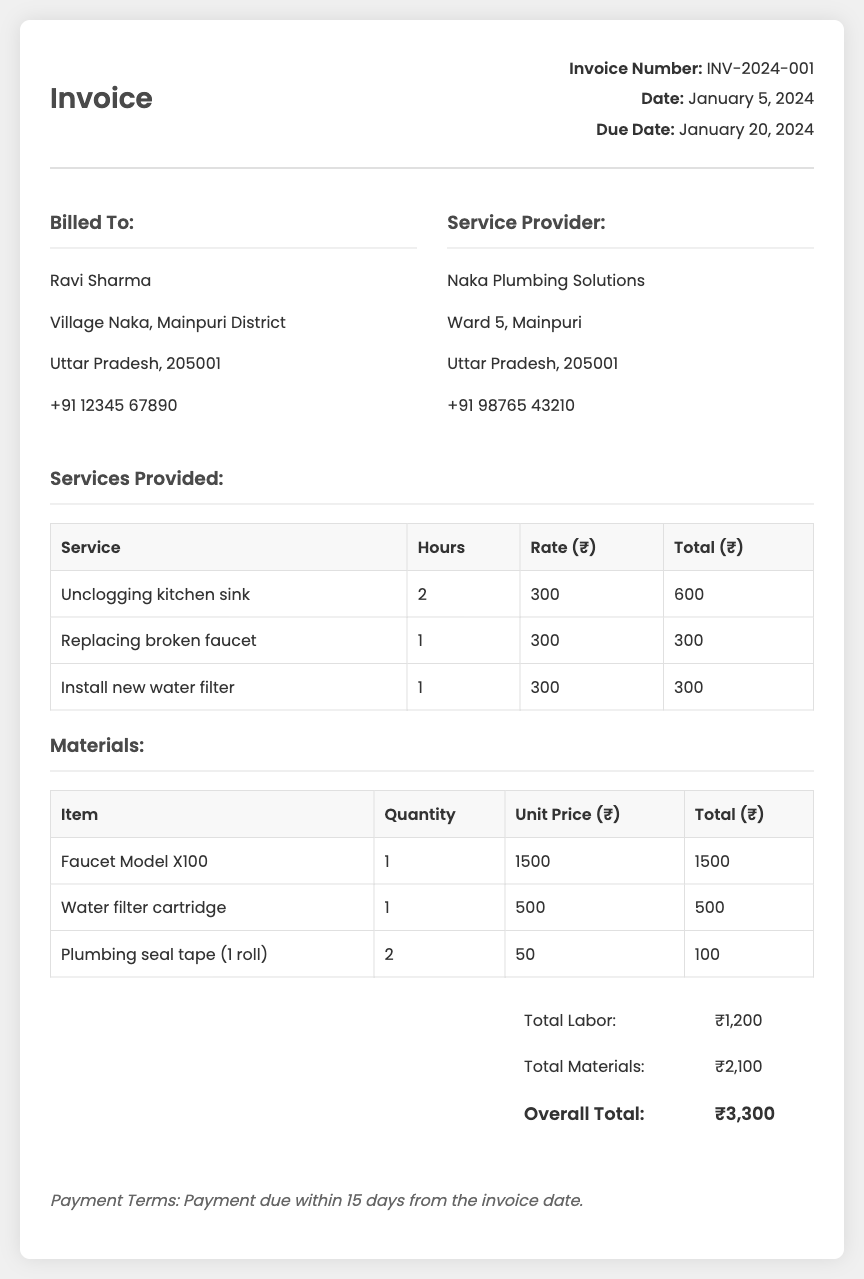What is the invoice number? The invoice number is listed at the top of the document for reference.
Answer: INV-2024-001 What is the total for materials? The total for materials is calculated by adding all material costs listed in the document.
Answer: ₹2,100 Who is billed in this invoice? The document specifies who is being billed in the "Billed To" section.
Answer: Ravi Sharma What service took the most hours? This question examines the services table to find which service required the highest amount of hours.
Answer: Unclogging kitchen sink What is the due date for payment? The due date is mentioned in the invoice details section, indicating when payment is expected.
Answer: January 20, 2024 What was the unit price of the faucet? The unit price for the faucet is specified in the materials section of the invoice.
Answer: ₹1500 What are the payment terms? The payment terms provide information on how long the client has to make the payment after receiving the invoice.
Answer: Payment due within 15 days from the invoice date How many plumbing seal tapes were purchased? This question looks at the materials table to determine the quantity of the plumbing seal tape item bought.
Answer: 2 What is the overall total for services and materials? The overall total is the sum of totals for labor and materials provided in the total section.
Answer: ₹3,300 